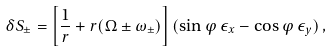<formula> <loc_0><loc_0><loc_500><loc_500>\delta S _ { \pm } = \left [ \frac { 1 } { r } + r ( \Omega \pm \omega _ { \pm } ) \right ] ( \sin { \varphi } \, \epsilon _ { x } - \cos { \varphi } \, \epsilon _ { y } ) \, ,</formula> 